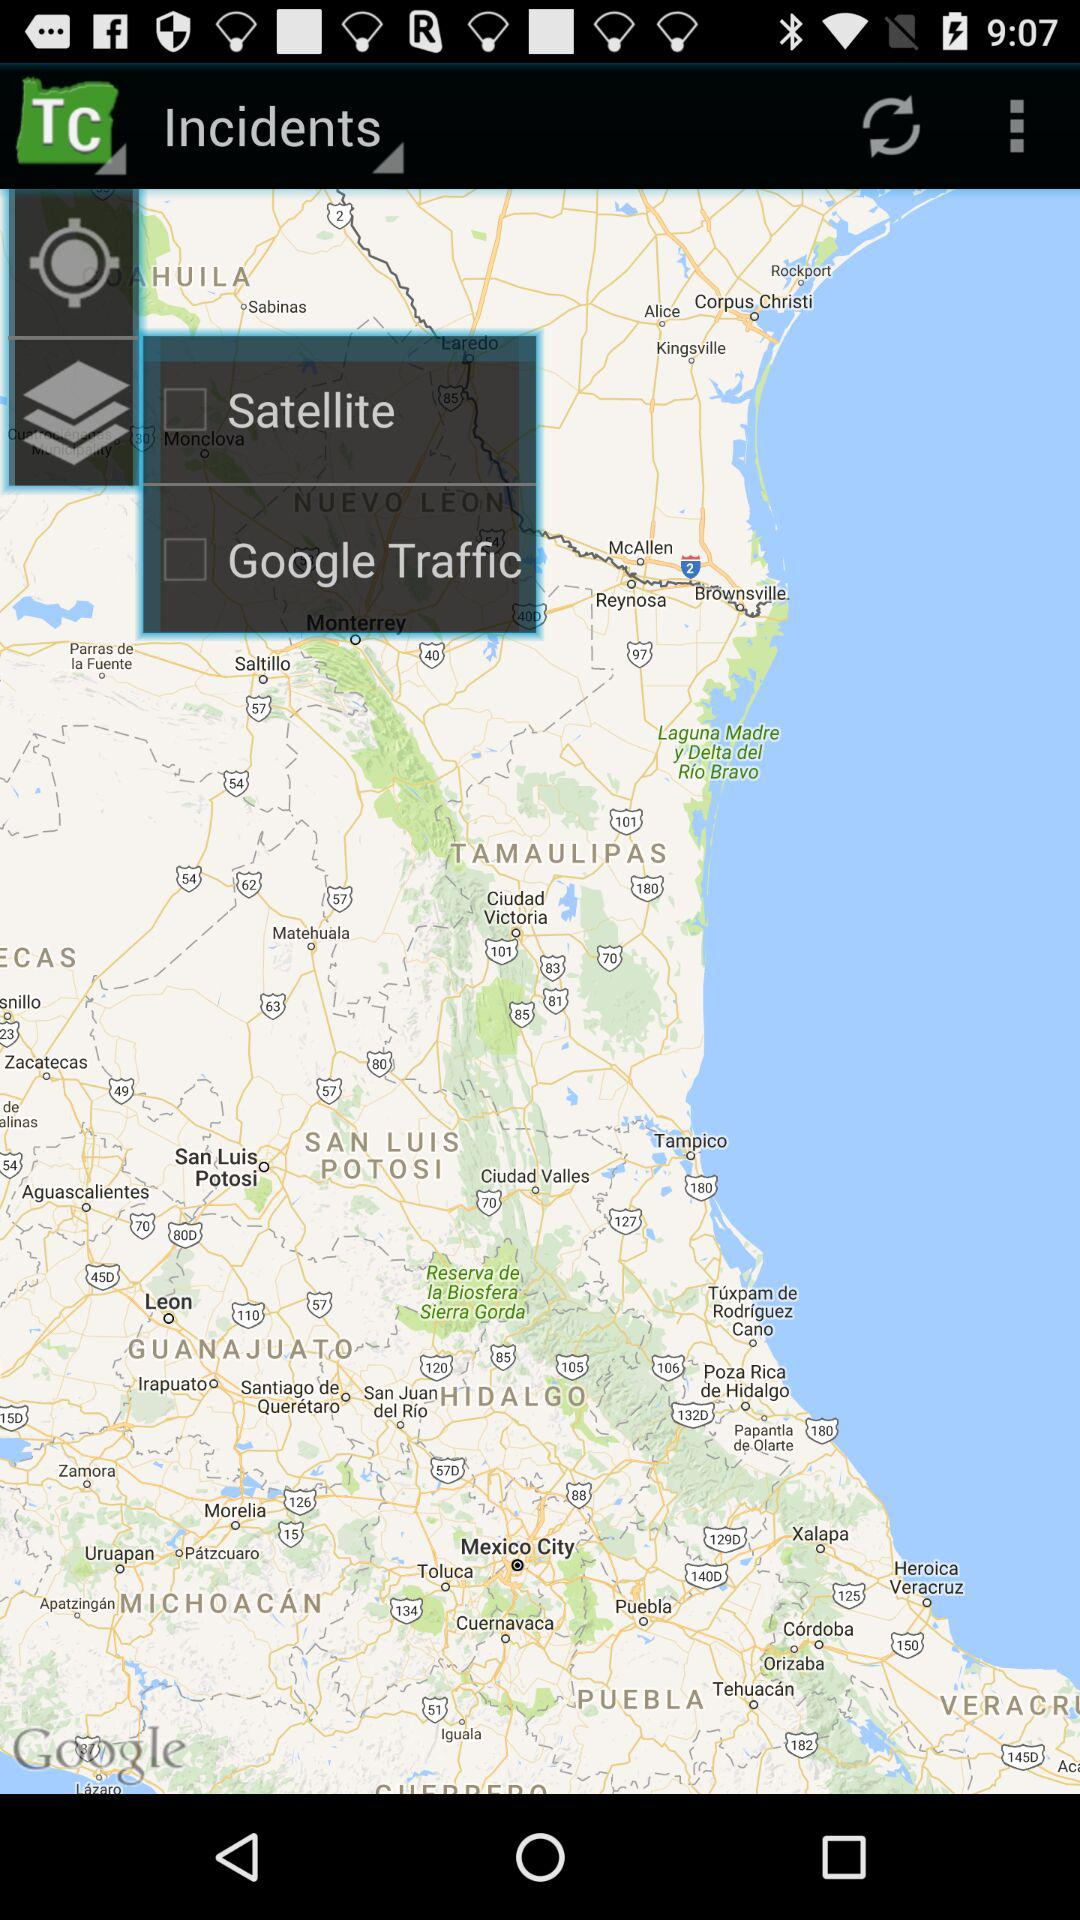How many checkboxes are on the map?
Answer the question using a single word or phrase. 2 